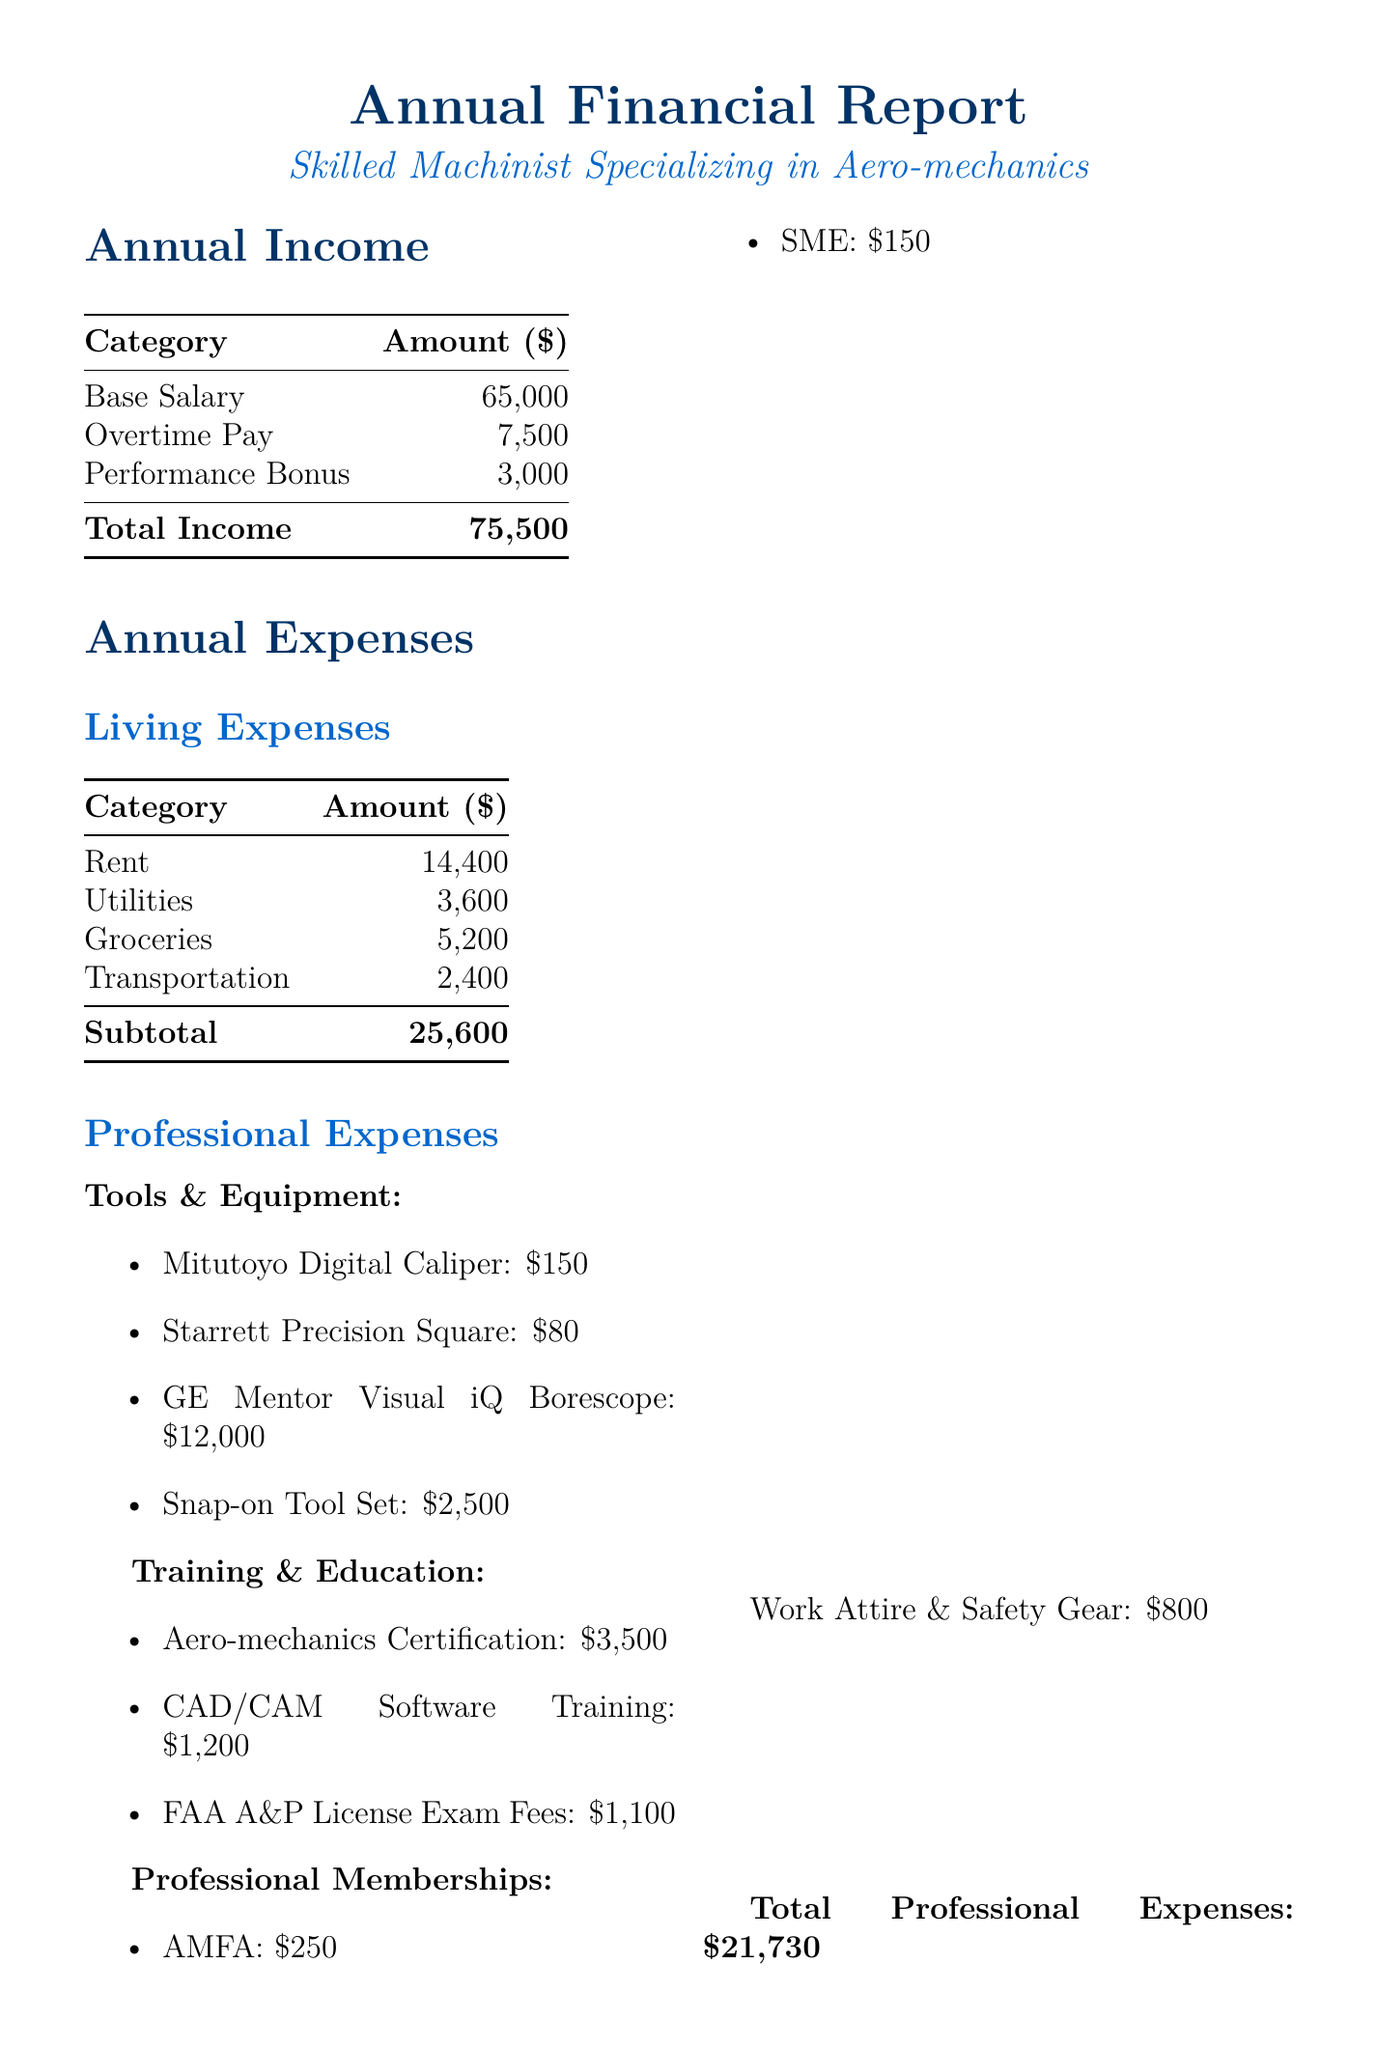what is the total income? The total income is the sum of the base salary, overtime pay, and performance bonus, which totals $65,000 + $7,500 + $3,000 = $75,500.
Answer: $75,500 how much is spent on taxes and insurance? The subtotal for taxes and insurance includes income tax, health insurance, and professional liability insurance, totaling $11,000 + $3,600 + $1,200 = $15,800.
Answer: $15,800 what is the cost of the GE Mentor Visual iQ Borescope? The document lists the cost for the GE Mentor Visual iQ Borescope as $12,000.
Answer: $12,000 how much is allocated for the Aero-mechanics Certification Course? The document specifies that the Aero-mechanics Certification Course costs $3,500.
Answer: $3,500 what is the total amount spent on professional expenses? The total professional expenses sum up all listed categories including tools, training, memberships, and work attire, totaling $21,730.
Answer: $21,730 what is the net balance at the end of the year? The net balance is calculated by subtracting total expenses from total income: $75,500 - $63,130 = $4,170.
Answer: $4,170 how much is allocated for the emergency fund? The document indicates that $3,000 is set aside for the emergency fund.
Answer: $3,000 how much does the Snap-on Tool Set cost? The cost of the Snap-on Tool Set is stated as $2,500.
Answer: $2,500 what is the total for living expenses? The subtotal for living expenses is the sum of rent, utilities, groceries, and transportation, totalling $14,400 + $3,600 + $5,200 + $2,400 = $25,600.
Answer: $25,600 